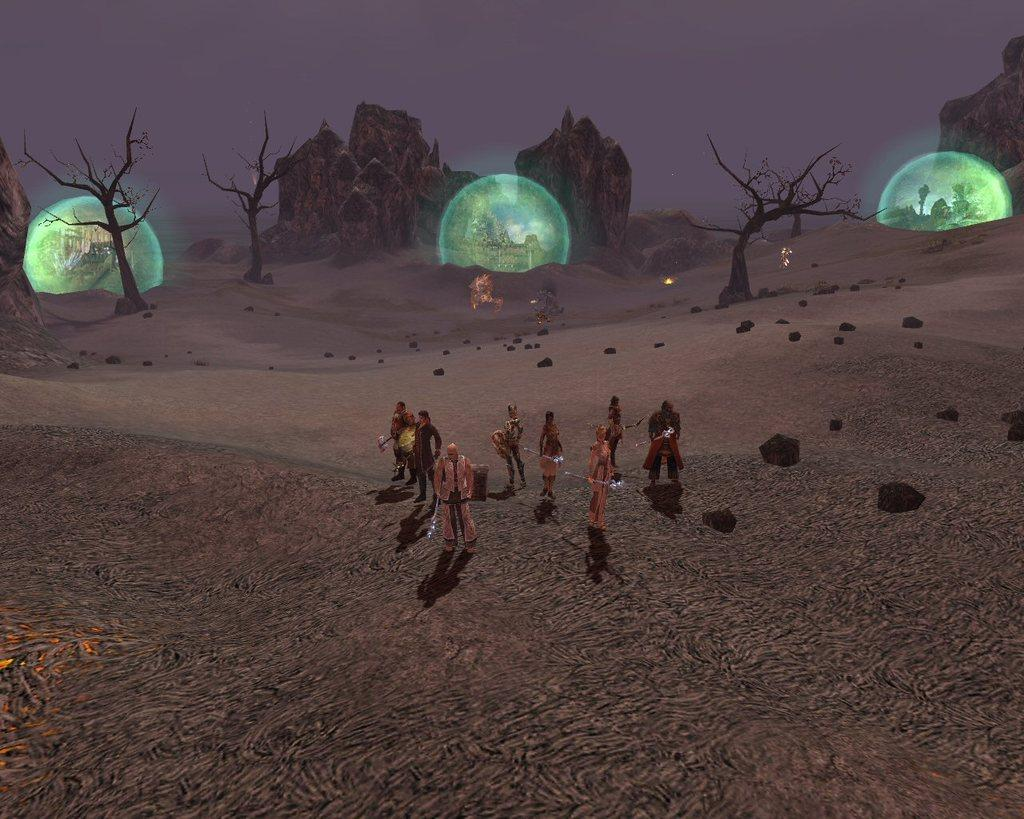What type of scene is depicted in the image? The image contains an animated scene. What objects are visible in the image that emit light? There are lighted balls visible in the image. What type of natural environment is present in the image? Trees and rocks are visible in the image. Where are the people located in the image? There are people on the sand in the image. What type of home can be seen in the image? There is no home present in the image; it contains an animated scene with lighted balls, trees, rocks, and people on the sand. What is the condition of the roof in the image? There is no roof present in the image. 